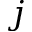Convert formula to latex. <formula><loc_0><loc_0><loc_500><loc_500>j</formula> 